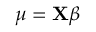<formula> <loc_0><loc_0><loc_500><loc_500>\mu = X { \beta } \,</formula> 